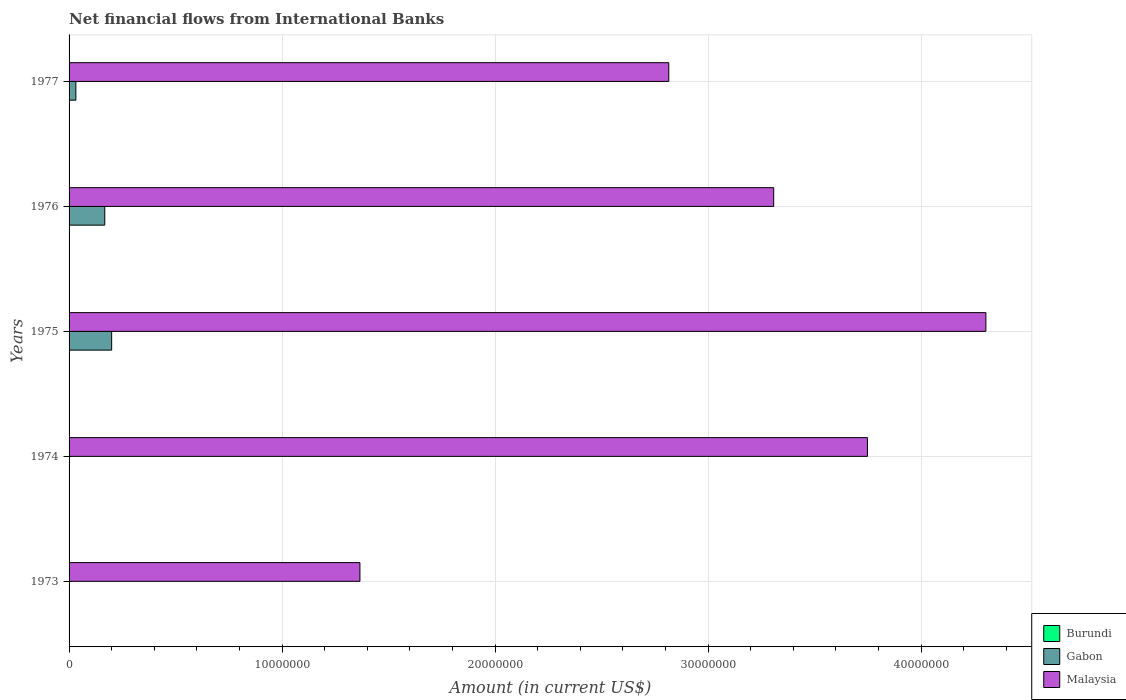How many different coloured bars are there?
Provide a succinct answer. 2. Are the number of bars per tick equal to the number of legend labels?
Provide a succinct answer. No. How many bars are there on the 2nd tick from the top?
Provide a short and direct response. 2. What is the label of the 4th group of bars from the top?
Your answer should be very brief. 1974. In how many cases, is the number of bars for a given year not equal to the number of legend labels?
Keep it short and to the point. 5. Across all years, what is the maximum net financial aid flows in Gabon?
Your answer should be very brief. 2.00e+06. Across all years, what is the minimum net financial aid flows in Malaysia?
Your answer should be very brief. 1.37e+07. In which year was the net financial aid flows in Malaysia maximum?
Provide a short and direct response. 1975. What is the total net financial aid flows in Burundi in the graph?
Offer a terse response. 0. What is the difference between the net financial aid flows in Malaysia in 1973 and that in 1974?
Make the answer very short. -2.38e+07. What is the difference between the net financial aid flows in Gabon in 1973 and the net financial aid flows in Malaysia in 1976?
Provide a succinct answer. -3.31e+07. What is the average net financial aid flows in Malaysia per year?
Keep it short and to the point. 3.11e+07. In the year 1975, what is the difference between the net financial aid flows in Gabon and net financial aid flows in Malaysia?
Offer a very short reply. -4.10e+07. What is the ratio of the net financial aid flows in Malaysia in 1974 to that in 1975?
Make the answer very short. 0.87. What is the difference between the highest and the second highest net financial aid flows in Malaysia?
Keep it short and to the point. 5.56e+06. What is the difference between the highest and the lowest net financial aid flows in Gabon?
Your answer should be compact. 2.00e+06. Is the sum of the net financial aid flows in Malaysia in 1973 and 1976 greater than the maximum net financial aid flows in Burundi across all years?
Ensure brevity in your answer.  Yes. Is it the case that in every year, the sum of the net financial aid flows in Burundi and net financial aid flows in Malaysia is greater than the net financial aid flows in Gabon?
Provide a succinct answer. Yes. How many bars are there?
Your response must be concise. 8. Does the graph contain any zero values?
Keep it short and to the point. Yes. Where does the legend appear in the graph?
Offer a very short reply. Bottom right. How many legend labels are there?
Provide a short and direct response. 3. How are the legend labels stacked?
Provide a short and direct response. Vertical. What is the title of the graph?
Ensure brevity in your answer.  Net financial flows from International Banks. What is the Amount (in current US$) of Malaysia in 1973?
Ensure brevity in your answer.  1.37e+07. What is the Amount (in current US$) of Malaysia in 1974?
Your answer should be compact. 3.75e+07. What is the Amount (in current US$) in Burundi in 1975?
Your answer should be very brief. 0. What is the Amount (in current US$) of Gabon in 1975?
Offer a terse response. 2.00e+06. What is the Amount (in current US$) of Malaysia in 1975?
Ensure brevity in your answer.  4.30e+07. What is the Amount (in current US$) in Gabon in 1976?
Keep it short and to the point. 1.68e+06. What is the Amount (in current US$) of Malaysia in 1976?
Your response must be concise. 3.31e+07. What is the Amount (in current US$) of Burundi in 1977?
Ensure brevity in your answer.  0. What is the Amount (in current US$) of Gabon in 1977?
Provide a succinct answer. 3.19e+05. What is the Amount (in current US$) of Malaysia in 1977?
Give a very brief answer. 2.82e+07. Across all years, what is the maximum Amount (in current US$) in Gabon?
Make the answer very short. 2.00e+06. Across all years, what is the maximum Amount (in current US$) of Malaysia?
Provide a succinct answer. 4.30e+07. Across all years, what is the minimum Amount (in current US$) of Gabon?
Provide a succinct answer. 0. Across all years, what is the minimum Amount (in current US$) in Malaysia?
Provide a succinct answer. 1.37e+07. What is the total Amount (in current US$) of Burundi in the graph?
Offer a very short reply. 0. What is the total Amount (in current US$) of Gabon in the graph?
Offer a very short reply. 3.99e+06. What is the total Amount (in current US$) of Malaysia in the graph?
Your response must be concise. 1.55e+08. What is the difference between the Amount (in current US$) of Malaysia in 1973 and that in 1974?
Provide a succinct answer. -2.38e+07. What is the difference between the Amount (in current US$) of Malaysia in 1973 and that in 1975?
Your answer should be very brief. -2.94e+07. What is the difference between the Amount (in current US$) of Malaysia in 1973 and that in 1976?
Give a very brief answer. -1.94e+07. What is the difference between the Amount (in current US$) of Malaysia in 1973 and that in 1977?
Keep it short and to the point. -1.45e+07. What is the difference between the Amount (in current US$) in Malaysia in 1974 and that in 1975?
Your answer should be compact. -5.56e+06. What is the difference between the Amount (in current US$) in Malaysia in 1974 and that in 1976?
Offer a very short reply. 4.40e+06. What is the difference between the Amount (in current US$) of Malaysia in 1974 and that in 1977?
Offer a terse response. 9.33e+06. What is the difference between the Amount (in current US$) in Gabon in 1975 and that in 1976?
Offer a very short reply. 3.24e+05. What is the difference between the Amount (in current US$) in Malaysia in 1975 and that in 1976?
Offer a very short reply. 9.96e+06. What is the difference between the Amount (in current US$) of Gabon in 1975 and that in 1977?
Provide a succinct answer. 1.68e+06. What is the difference between the Amount (in current US$) in Malaysia in 1975 and that in 1977?
Your answer should be compact. 1.49e+07. What is the difference between the Amount (in current US$) in Gabon in 1976 and that in 1977?
Make the answer very short. 1.36e+06. What is the difference between the Amount (in current US$) in Malaysia in 1976 and that in 1977?
Your answer should be very brief. 4.92e+06. What is the difference between the Amount (in current US$) in Gabon in 1975 and the Amount (in current US$) in Malaysia in 1976?
Your response must be concise. -3.11e+07. What is the difference between the Amount (in current US$) in Gabon in 1975 and the Amount (in current US$) in Malaysia in 1977?
Your answer should be compact. -2.62e+07. What is the difference between the Amount (in current US$) in Gabon in 1976 and the Amount (in current US$) in Malaysia in 1977?
Your answer should be very brief. -2.65e+07. What is the average Amount (in current US$) in Gabon per year?
Your answer should be compact. 7.99e+05. What is the average Amount (in current US$) in Malaysia per year?
Make the answer very short. 3.11e+07. In the year 1975, what is the difference between the Amount (in current US$) in Gabon and Amount (in current US$) in Malaysia?
Ensure brevity in your answer.  -4.10e+07. In the year 1976, what is the difference between the Amount (in current US$) of Gabon and Amount (in current US$) of Malaysia?
Your response must be concise. -3.14e+07. In the year 1977, what is the difference between the Amount (in current US$) of Gabon and Amount (in current US$) of Malaysia?
Your answer should be compact. -2.78e+07. What is the ratio of the Amount (in current US$) of Malaysia in 1973 to that in 1974?
Ensure brevity in your answer.  0.36. What is the ratio of the Amount (in current US$) of Malaysia in 1973 to that in 1975?
Ensure brevity in your answer.  0.32. What is the ratio of the Amount (in current US$) of Malaysia in 1973 to that in 1976?
Offer a very short reply. 0.41. What is the ratio of the Amount (in current US$) of Malaysia in 1973 to that in 1977?
Give a very brief answer. 0.48. What is the ratio of the Amount (in current US$) of Malaysia in 1974 to that in 1975?
Your answer should be compact. 0.87. What is the ratio of the Amount (in current US$) in Malaysia in 1974 to that in 1976?
Provide a short and direct response. 1.13. What is the ratio of the Amount (in current US$) in Malaysia in 1974 to that in 1977?
Offer a terse response. 1.33. What is the ratio of the Amount (in current US$) of Gabon in 1975 to that in 1976?
Keep it short and to the point. 1.19. What is the ratio of the Amount (in current US$) in Malaysia in 1975 to that in 1976?
Ensure brevity in your answer.  1.3. What is the ratio of the Amount (in current US$) of Gabon in 1975 to that in 1977?
Offer a terse response. 6.27. What is the ratio of the Amount (in current US$) in Malaysia in 1975 to that in 1977?
Make the answer very short. 1.53. What is the ratio of the Amount (in current US$) of Gabon in 1976 to that in 1977?
Offer a very short reply. 5.25. What is the ratio of the Amount (in current US$) in Malaysia in 1976 to that in 1977?
Give a very brief answer. 1.17. What is the difference between the highest and the second highest Amount (in current US$) of Gabon?
Ensure brevity in your answer.  3.24e+05. What is the difference between the highest and the second highest Amount (in current US$) in Malaysia?
Your response must be concise. 5.56e+06. What is the difference between the highest and the lowest Amount (in current US$) in Gabon?
Provide a short and direct response. 2.00e+06. What is the difference between the highest and the lowest Amount (in current US$) of Malaysia?
Keep it short and to the point. 2.94e+07. 